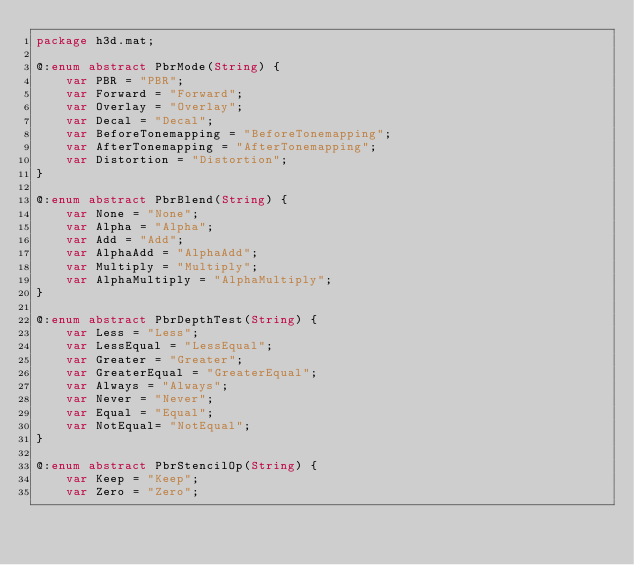Convert code to text. <code><loc_0><loc_0><loc_500><loc_500><_Haxe_>package h3d.mat;

@:enum abstract PbrMode(String) {
	var PBR = "PBR";
	var Forward = "Forward";
	var Overlay = "Overlay";
	var Decal = "Decal";
	var BeforeTonemapping = "BeforeTonemapping";
	var AfterTonemapping = "AfterTonemapping";
	var Distortion = "Distortion";
}

@:enum abstract PbrBlend(String) {
	var None = "None";
	var Alpha = "Alpha";
	var Add = "Add";
	var AlphaAdd = "AlphaAdd";
	var Multiply = "Multiply";
	var AlphaMultiply = "AlphaMultiply";
}

@:enum abstract PbrDepthTest(String) {
	var Less = "Less";
	var LessEqual = "LessEqual";
	var Greater = "Greater";
	var GreaterEqual = "GreaterEqual";
	var Always = "Always";
	var Never = "Never";
	var Equal = "Equal";
	var NotEqual= "NotEqual";
}

@:enum abstract PbrStencilOp(String) {
	var Keep = "Keep";
	var Zero = "Zero";</code> 